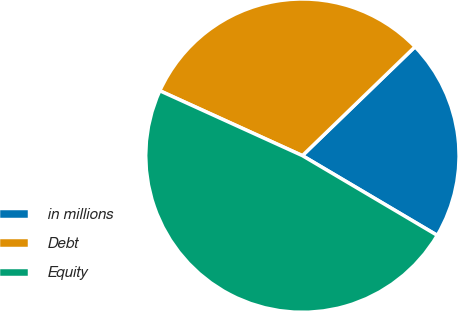Convert chart to OTSL. <chart><loc_0><loc_0><loc_500><loc_500><pie_chart><fcel>in millions<fcel>Debt<fcel>Equity<nl><fcel>20.73%<fcel>30.97%<fcel>48.3%<nl></chart> 